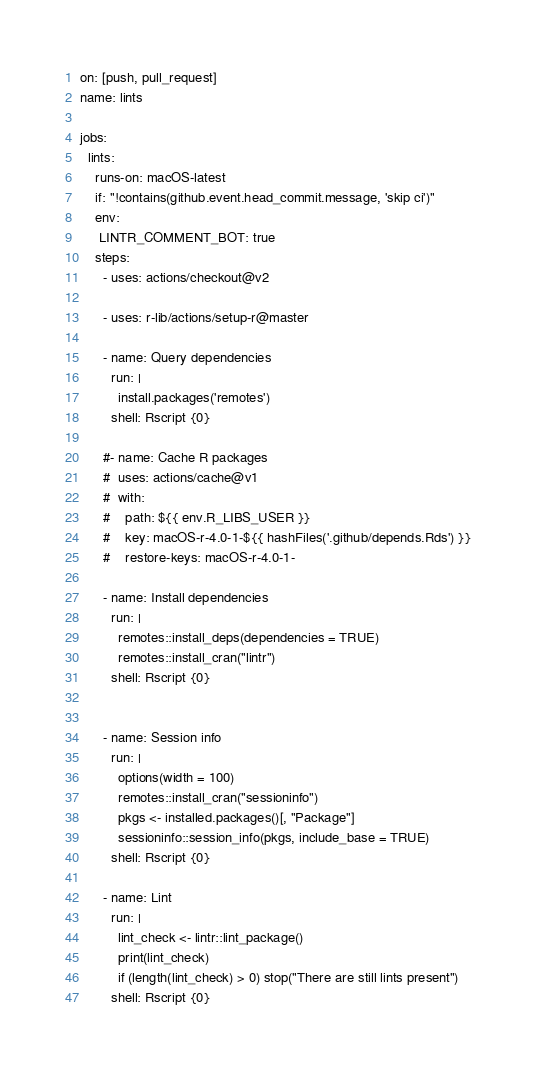Convert code to text. <code><loc_0><loc_0><loc_500><loc_500><_YAML_>on: [push, pull_request]
name: lints

jobs:
  lints:
    runs-on: macOS-latest
    if: "!contains(github.event.head_commit.message, 'skip ci')"
    env:
     LINTR_COMMENT_BOT: true
    steps:
      - uses: actions/checkout@v2

      - uses: r-lib/actions/setup-r@master

      - name: Query dependencies
        run: |
          install.packages('remotes')
        shell: Rscript {0}

      #- name: Cache R packages
      #  uses: actions/cache@v1
      #  with:
      #    path: ${{ env.R_LIBS_USER }}
      #    key: macOS-r-4.0-1-${{ hashFiles('.github/depends.Rds') }}
      #    restore-keys: macOS-r-4.0-1-

      - name: Install dependencies
        run: |
          remotes::install_deps(dependencies = TRUE)
          remotes::install_cran("lintr")
        shell: Rscript {0}


      - name: Session info
        run: |
          options(width = 100)
          remotes::install_cran("sessioninfo")
          pkgs <- installed.packages()[, "Package"]
          sessioninfo::session_info(pkgs, include_base = TRUE)
        shell: Rscript {0}

      - name: Lint
        run: |
          lint_check <- lintr::lint_package()
          print(lint_check)
          if (length(lint_check) > 0) stop("There are still lints present")
        shell: Rscript {0}
</code> 